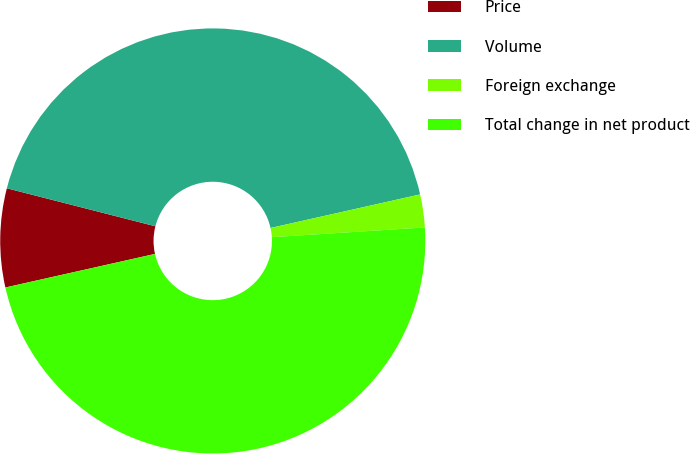Convert chart to OTSL. <chart><loc_0><loc_0><loc_500><loc_500><pie_chart><fcel>Price<fcel>Volume<fcel>Foreign exchange<fcel>Total change in net product<nl><fcel>7.5%<fcel>42.5%<fcel>2.5%<fcel>47.5%<nl></chart> 